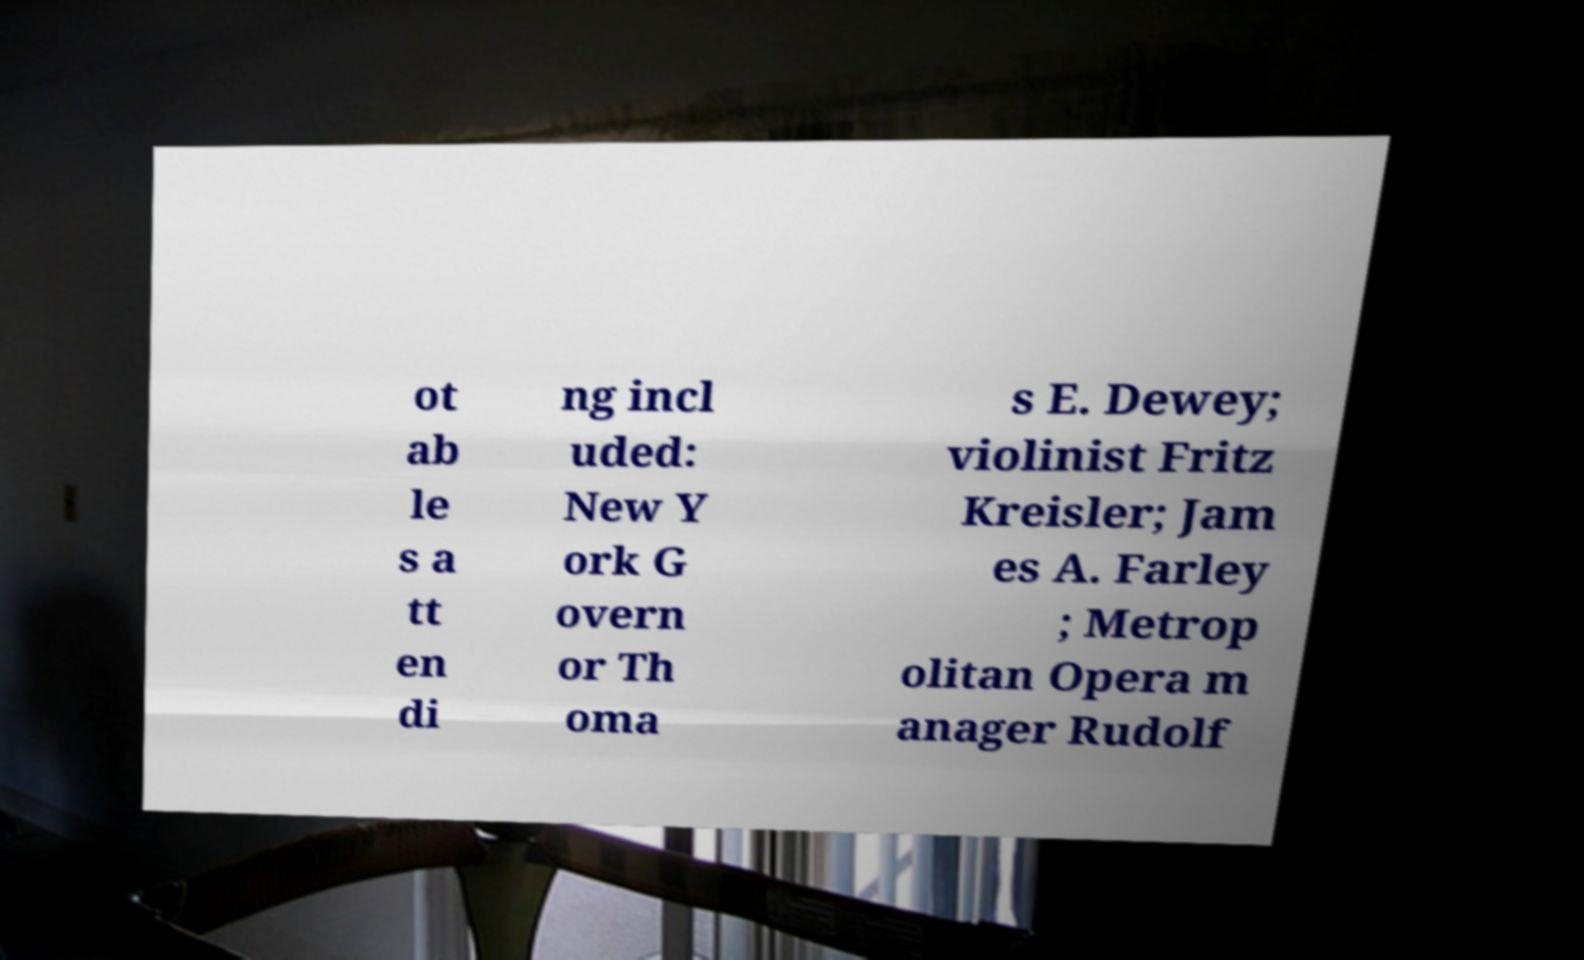Can you read and provide the text displayed in the image?This photo seems to have some interesting text. Can you extract and type it out for me? ot ab le s a tt en di ng incl uded: New Y ork G overn or Th oma s E. Dewey; violinist Fritz Kreisler; Jam es A. Farley ; Metrop olitan Opera m anager Rudolf 